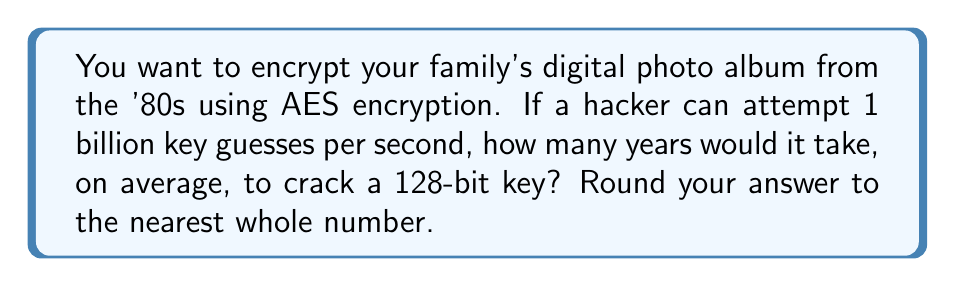Provide a solution to this math problem. Let's approach this step-by-step:

1) A 128-bit key has $2^{128}$ possible combinations.

2) On average, an attacker would need to try half of these combinations to find the correct key. So, the expected number of attempts is:

   $$\frac{2^{128}}{2} = 2^{127}$$

3) The hacker can make 1 billion ($10^9$) attempts per second. To find the number of seconds needed, we divide the number of attempts by the attempts per second:

   $$\frac{2^{127}}{10^9} \text{ seconds}$$

4) To convert this to years, we need to divide by the number of seconds in a year:
   
   $$\frac{2^{127}}{10^9 \times 365 \times 24 \times 60 \times 60} \text{ years}$$

5) Let's calculate this:
   
   $$\frac{2^{127}}{10^9 \times 365 \times 24 \times 60 \times 60} \approx 5.4 \times 10^{21} \text{ years}$$

6) Rounding to the nearest whole number:

   $5.4 \times 10^{21} \approx 5 \times 10^{21}$ years

This incredibly large number demonstrates why 128-bit AES encryption is considered very secure for protecting your '80s family photos!
Answer: $5 \times 10^{21}$ years 